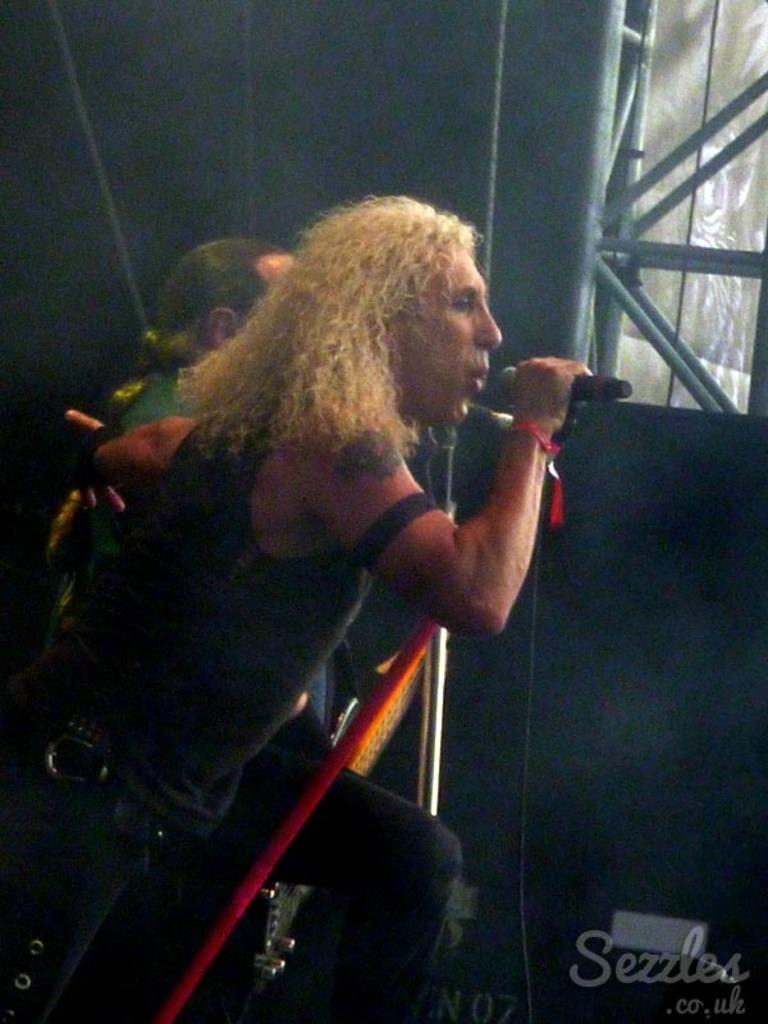How many people are in the image? There are two people in the image. What objects can be seen in the image related to music? There is a mic and a guitar in the image. What other objects can be seen in the image? There are rods and a screen in the image. What is the color of the background in the image? The background of the image is dark. Is there any text visible in the image? Yes, there is some text in the bottom right corner of the image. What type of skin condition can be seen on the people in the image? There is no indication of any skin condition on the people in the image; the provided facts do not mention anything about their skin. How many trucks are visible in the image? There are no trucks present in the image. 